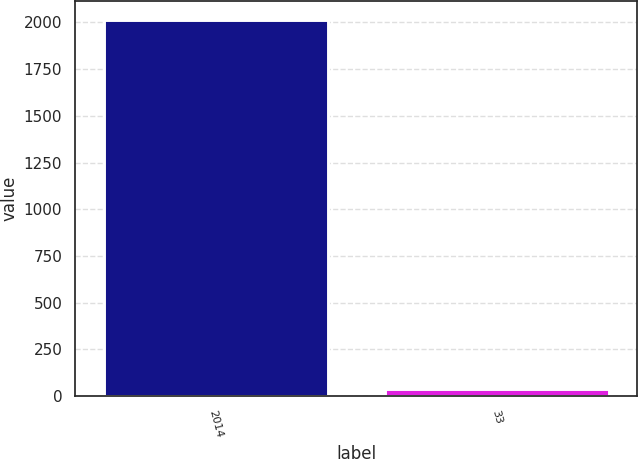<chart> <loc_0><loc_0><loc_500><loc_500><bar_chart><fcel>2014<fcel>33<nl><fcel>2012<fcel>37<nl></chart> 